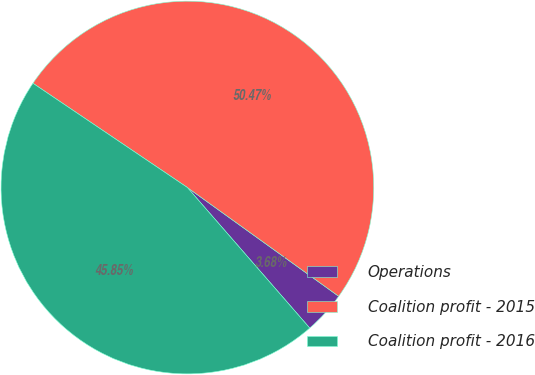Convert chart to OTSL. <chart><loc_0><loc_0><loc_500><loc_500><pie_chart><fcel>Operations<fcel>Coalition profit - 2015<fcel>Coalition profit - 2016<nl><fcel>3.68%<fcel>50.47%<fcel>45.85%<nl></chart> 